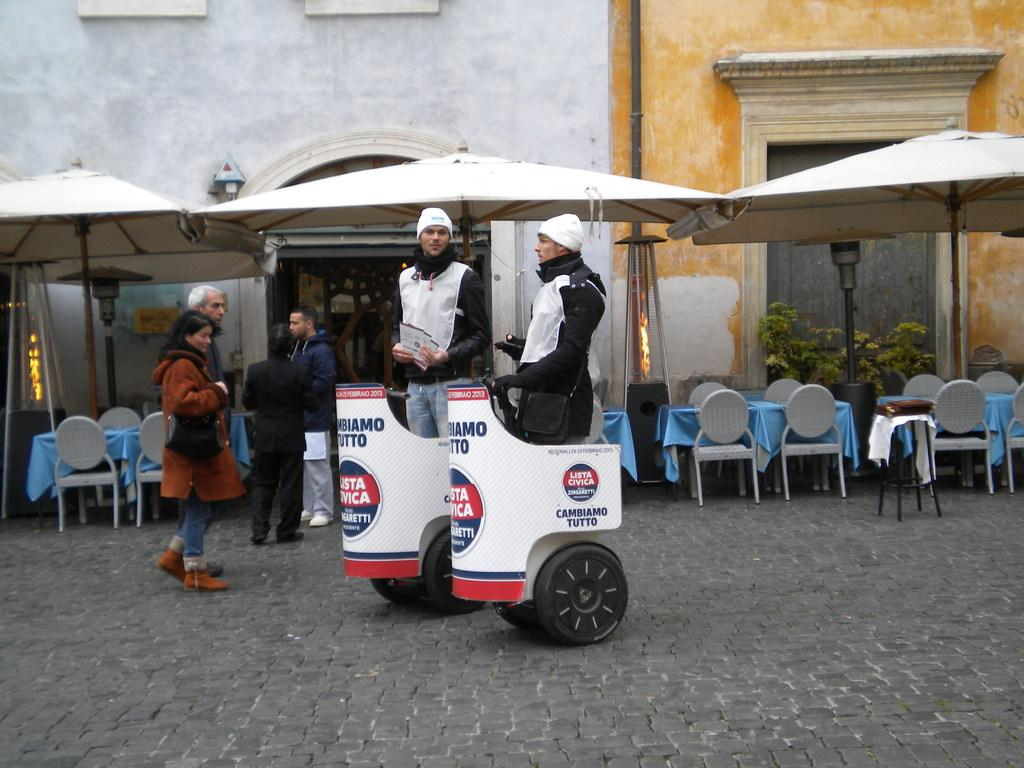What are the two men doing in the image? The two men are standing on a vehicle in the image. What else can be seen in the image besides the men on the vehicle? There are people standing on the road in the image. What type of structure is visible in the image? There is a building visible in the image. What type of advertisement can be seen on the shirt of the man standing on the vehicle? There is no shirt visible on the man standing on the vehicle in the image, nor is there any advertisement present. 